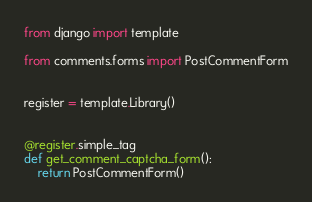Convert code to text. <code><loc_0><loc_0><loc_500><loc_500><_Python_>from django import template

from comments.forms import PostCommentForm


register = template.Library()


@register.simple_tag
def get_comment_captcha_form():
    return PostCommentForm()
</code> 